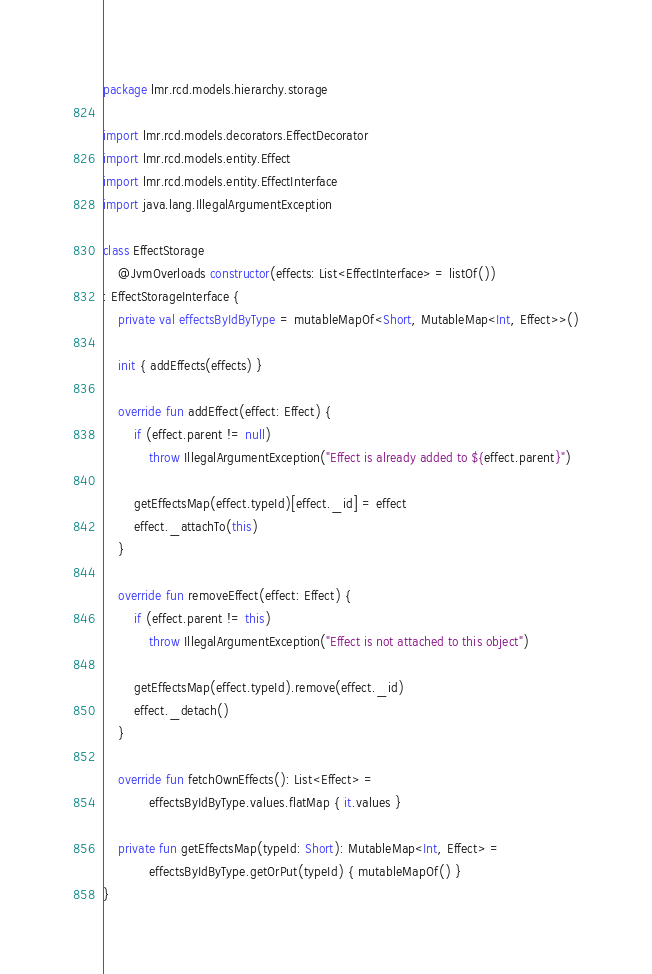Convert code to text. <code><loc_0><loc_0><loc_500><loc_500><_Kotlin_>package lmr.rcd.models.hierarchy.storage

import lmr.rcd.models.decorators.EffectDecorator
import lmr.rcd.models.entity.Effect
import lmr.rcd.models.entity.EffectInterface
import java.lang.IllegalArgumentException

class EffectStorage
    @JvmOverloads constructor(effects: List<EffectInterface> = listOf())
: EffectStorageInterface {
    private val effectsByIdByType = mutableMapOf<Short, MutableMap<Int, Effect>>()

    init { addEffects(effects) }

    override fun addEffect(effect: Effect) {
        if (effect.parent != null)
            throw IllegalArgumentException("Effect is already added to ${effect.parent}")

        getEffectsMap(effect.typeId)[effect._id] = effect
        effect._attachTo(this)
    }

    override fun removeEffect(effect: Effect) {
        if (effect.parent != this)
            throw IllegalArgumentException("Effect is not attached to this object")

        getEffectsMap(effect.typeId).remove(effect._id)
        effect._detach()
    }

    override fun fetchOwnEffects(): List<Effect> =
            effectsByIdByType.values.flatMap { it.values }

    private fun getEffectsMap(typeId: Short): MutableMap<Int, Effect> =
            effectsByIdByType.getOrPut(typeId) { mutableMapOf() }
}</code> 